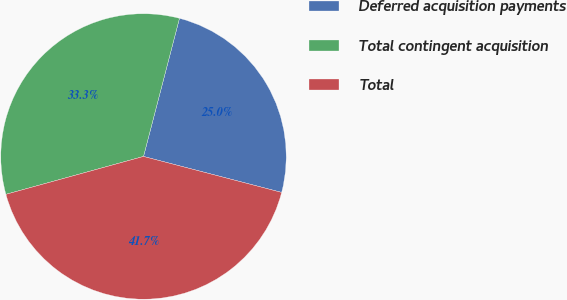<chart> <loc_0><loc_0><loc_500><loc_500><pie_chart><fcel>Deferred acquisition payments<fcel>Total contingent acquisition<fcel>Total<nl><fcel>25.0%<fcel>33.33%<fcel>41.67%<nl></chart> 